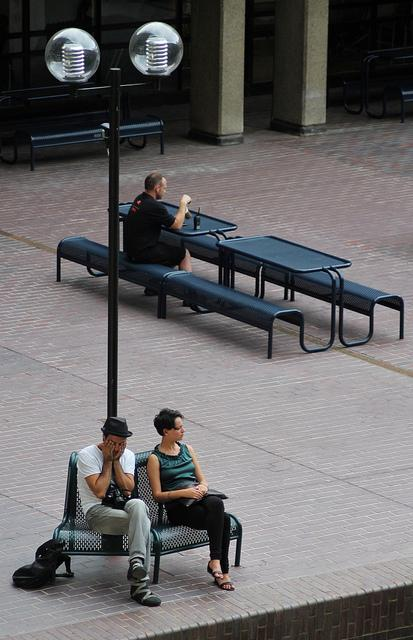What is the man at the table doing? Please explain your reasoning. drinking. The man at the table is awake and is sitting. 